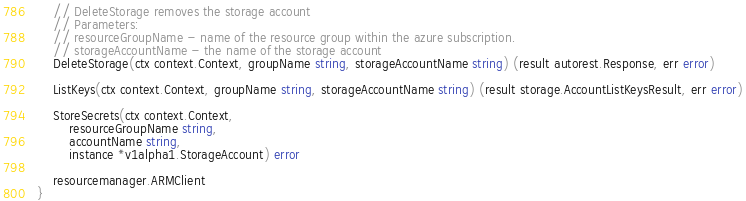Convert code to text. <code><loc_0><loc_0><loc_500><loc_500><_Go_>	// DeleteStorage removes the storage account
	// Parameters:
	// resourceGroupName - name of the resource group within the azure subscription.
	// storageAccountName - the name of the storage account
	DeleteStorage(ctx context.Context, groupName string, storageAccountName string) (result autorest.Response, err error)

	ListKeys(ctx context.Context, groupName string, storageAccountName string) (result storage.AccountListKeysResult, err error)

	StoreSecrets(ctx context.Context,
		resourceGroupName string,
		accountName string,
		instance *v1alpha1.StorageAccount) error

	resourcemanager.ARMClient
}
</code> 